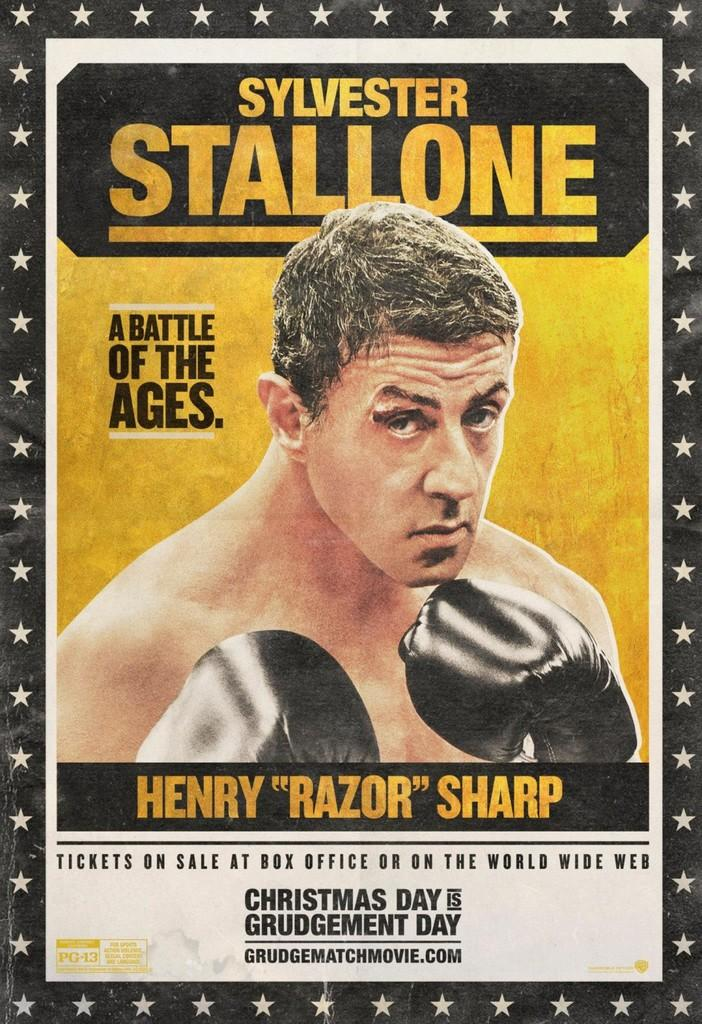What is present in the image that features an image? There is a poster in the image that features an image. What type of image is on the poster? The poster has an image of a man. What else can be found on the poster besides the image? There is text on the poster. What type of zephyr is depicted in the image? There is no zephyr present in the image; it features a poster with an image of a man and text. 